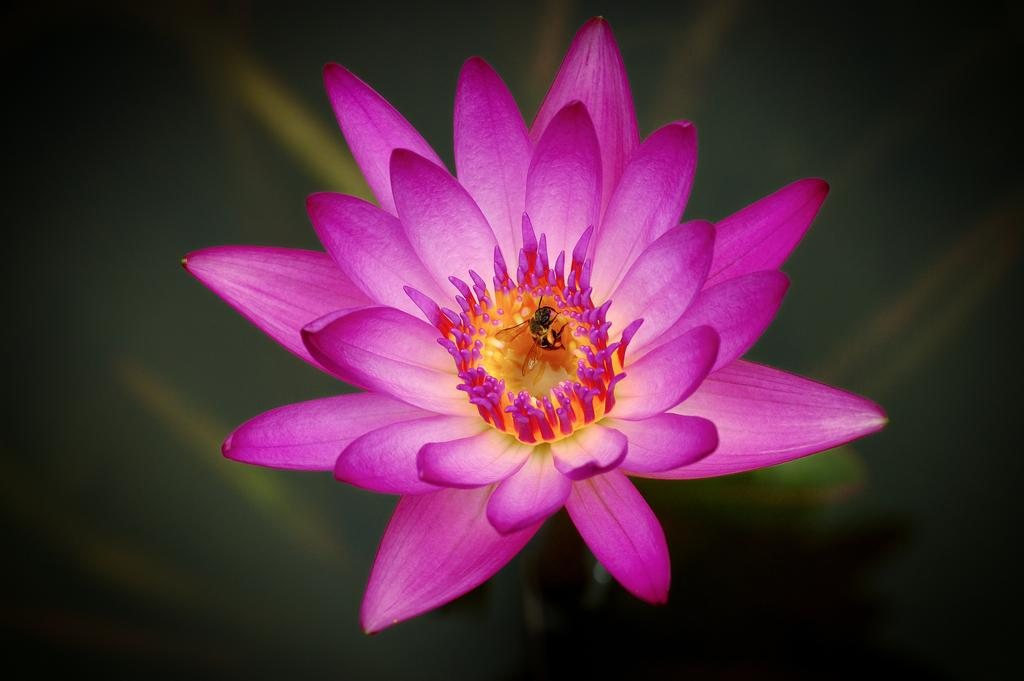What is one living organism that can be seen in the image? There is a flower in the image. What other living organism can be seen in the image? There is an insect in the image. How would you describe the overall color scheme of the image? The background of the image is dark. What type of friction can be observed between the flower and the insect in the image? There is no friction between the flower and the insect in the image, as they are not interacting in a way that would cause friction. 